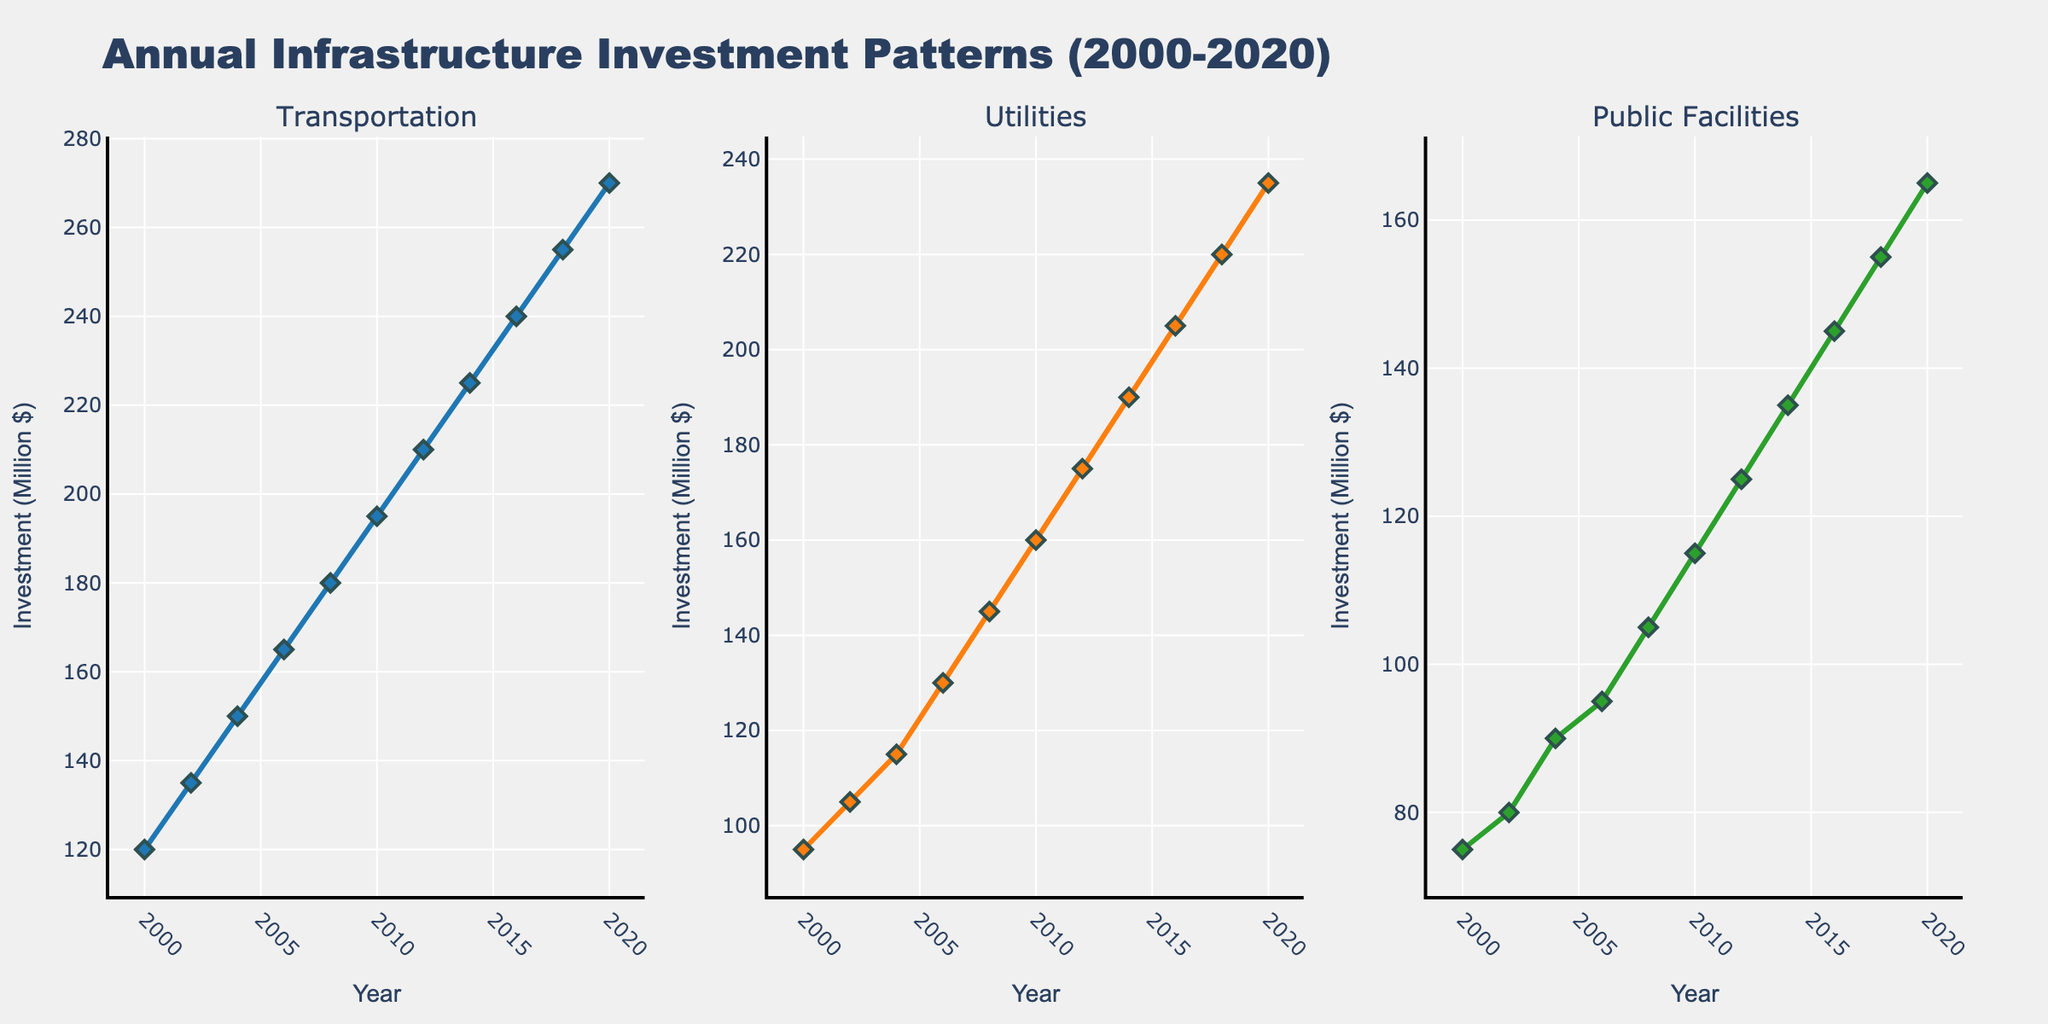What is the title of the figure? The title of the figure is displayed prominently at the top of the plot. It is "Annual Infrastructure Investment Patterns (2000-2020)"
Answer: Annual Infrastructure Investment Patterns (2000-2020) What are the sectors presented in the subplots? The labels at the top of each subplot indicate the sectors. They are "Transportation", "Utilities", and "Public Facilities"
Answer: Transportation, Utilities, Public Facilities How many data points are there for each sector? The x-axis represents years from 2000 to 2020 inclusive, and data seems to be plotted every two years. Counting the intervals, there are 11 data points for each sector
Answer: 11 Which sector had the highest investment in 2006? By looking at the y-values for the year 2006 in each subplot, Transportation had the highest value of 165 million dollars
Answer: Transportation What is the total investment in 2020 across all sectors? Sum the values for each sector in the year 2020: Transportation (270) + Utilities (235) + Public Facilities (165) = 670 million dollars
Answer: 670 million dollars Which sector shows the greatest increase in investment from 2000 to 2020? Comparing the starting and ending values for each sector: 
Transportation: 270 - 120 = 150
Utilities: 235 - 95 = 140
Public Facilities: 165 - 75 = 90
Transportation shows the greatest increase of 150 million dollars
Answer: Transportation What is the average investment in Utilities over the entire time period? Sum the values for Utilities and divide by the number of data points: (95+105+115+130+145+160+175+190+205+220+235) / 11 = 176.36 million dollars
Answer: 176.36 million dollars In which year did Public Facilities see the steepest increase in investment compared to the previous data point? Calculate the difference between consecutive years:
2000-2002: 80-75 = 5
2002-2004: 90-80 = 10
2004-2006: 95-90 = 5
2006-2008: 105-95 = 10
2008-2010: 115-105 = 10
2010-2012: 125-115 = 10
2012-2014: 135-125 = 10
2014-2016: 145-135 = 10
2016-2018: 155-145 = 10
2018-2020: 165-155 = 10
The largest single increase was from 2002 to 2004 and 2006-2008 onward till 2018-2020, each with a 10 million-dollar increase
Answer: 2002-2004 and 2006-2008 till 2018-2020 Discuss the general trend observed in Transportation investment over the two decades. Looking at the line plot for Transportation, the trend is generally increasing. From 120 million dollars in 2000, it rises steadily to 270 million dollars in 2020, showing a consistent upward trend without any drops or plateaus
Answer: Increasing trend 